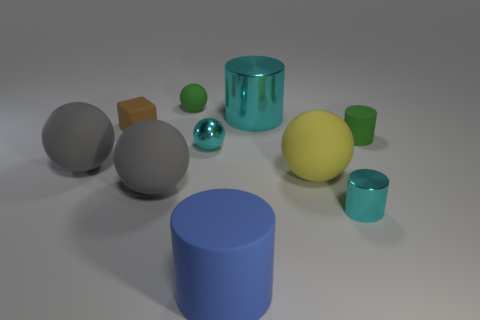Is there any other thing of the same color as the tiny rubber cube?
Offer a very short reply. No. Do the yellow matte thing and the green sphere have the same size?
Offer a very short reply. No. What number of objects are big cyan shiny cylinders to the right of the blue object or green matte things that are left of the large blue matte cylinder?
Keep it short and to the point. 2. The green thing that is behind the small green matte object in front of the brown object is made of what material?
Provide a succinct answer. Rubber. What number of other objects are the same material as the blue cylinder?
Give a very brief answer. 6. Do the blue object and the big cyan thing have the same shape?
Your answer should be very brief. Yes. What is the size of the cyan cylinder that is on the right side of the big cyan thing?
Ensure brevity in your answer.  Small. There is a yellow rubber sphere; does it have the same size as the green thing in front of the large metal cylinder?
Give a very brief answer. No. Is the number of small matte spheres that are left of the tiny green matte sphere less than the number of small red cylinders?
Provide a short and direct response. No. There is another cyan thing that is the same shape as the large cyan thing; what is it made of?
Keep it short and to the point. Metal. 